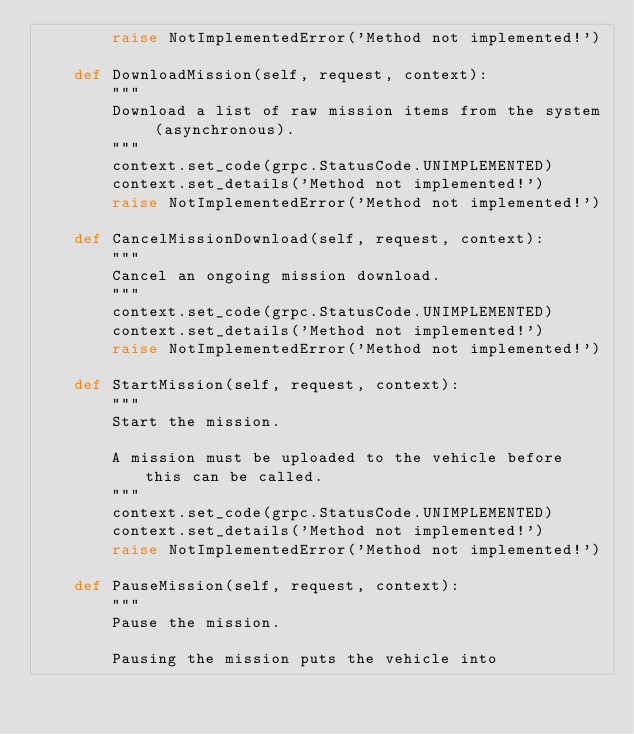Convert code to text. <code><loc_0><loc_0><loc_500><loc_500><_Python_>        raise NotImplementedError('Method not implemented!')

    def DownloadMission(self, request, context):
        """
        Download a list of raw mission items from the system (asynchronous).
        """
        context.set_code(grpc.StatusCode.UNIMPLEMENTED)
        context.set_details('Method not implemented!')
        raise NotImplementedError('Method not implemented!')

    def CancelMissionDownload(self, request, context):
        """
        Cancel an ongoing mission download.
        """
        context.set_code(grpc.StatusCode.UNIMPLEMENTED)
        context.set_details('Method not implemented!')
        raise NotImplementedError('Method not implemented!')

    def StartMission(self, request, context):
        """
        Start the mission.

        A mission must be uploaded to the vehicle before this can be called.
        """
        context.set_code(grpc.StatusCode.UNIMPLEMENTED)
        context.set_details('Method not implemented!')
        raise NotImplementedError('Method not implemented!')

    def PauseMission(self, request, context):
        """
        Pause the mission.

        Pausing the mission puts the vehicle into</code> 